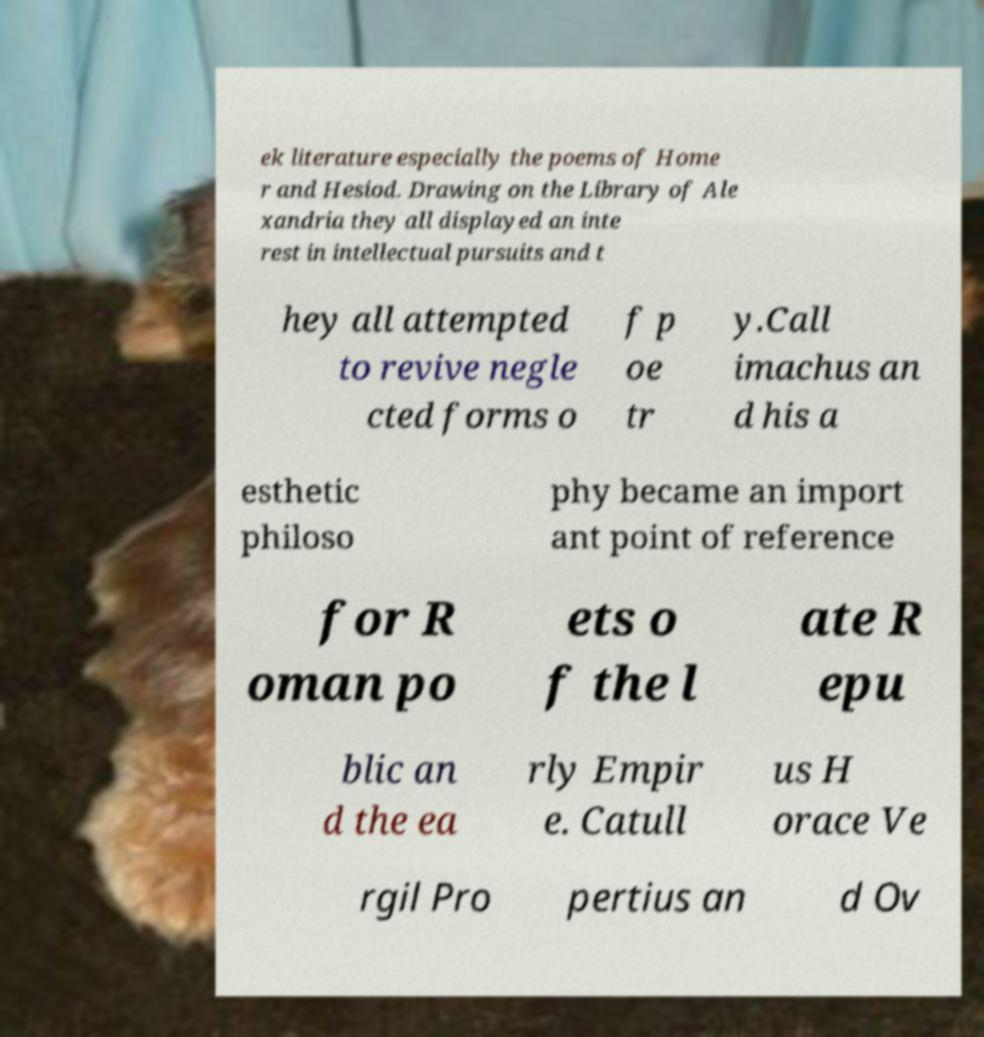I need the written content from this picture converted into text. Can you do that? ek literature especially the poems of Home r and Hesiod. Drawing on the Library of Ale xandria they all displayed an inte rest in intellectual pursuits and t hey all attempted to revive negle cted forms o f p oe tr y.Call imachus an d his a esthetic philoso phy became an import ant point of reference for R oman po ets o f the l ate R epu blic an d the ea rly Empir e. Catull us H orace Ve rgil Pro pertius an d Ov 